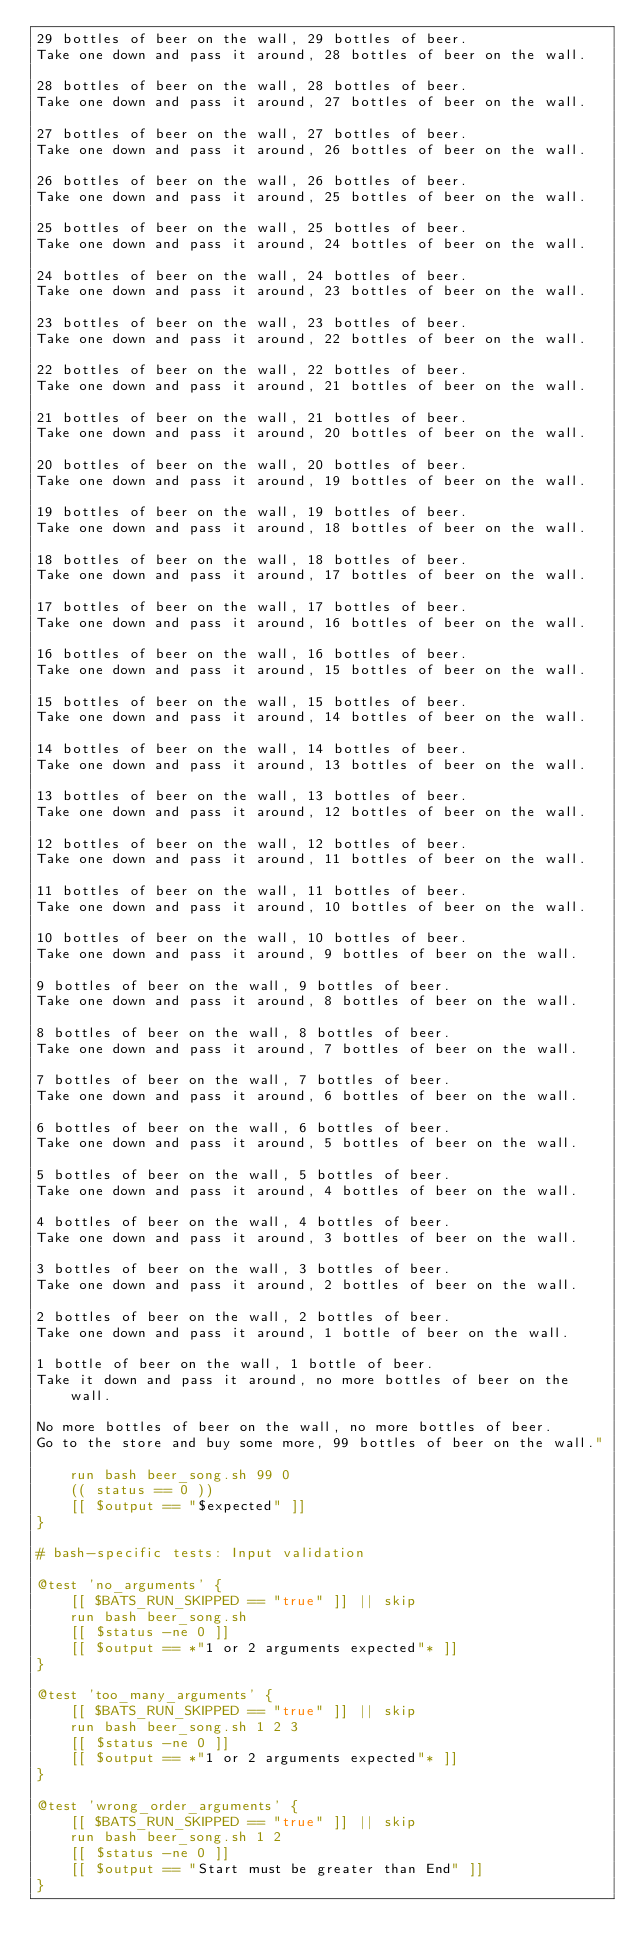Convert code to text. <code><loc_0><loc_0><loc_500><loc_500><_Bash_>29 bottles of beer on the wall, 29 bottles of beer.
Take one down and pass it around, 28 bottles of beer on the wall.

28 bottles of beer on the wall, 28 bottles of beer.
Take one down and pass it around, 27 bottles of beer on the wall.

27 bottles of beer on the wall, 27 bottles of beer.
Take one down and pass it around, 26 bottles of beer on the wall.

26 bottles of beer on the wall, 26 bottles of beer.
Take one down and pass it around, 25 bottles of beer on the wall.

25 bottles of beer on the wall, 25 bottles of beer.
Take one down and pass it around, 24 bottles of beer on the wall.

24 bottles of beer on the wall, 24 bottles of beer.
Take one down and pass it around, 23 bottles of beer on the wall.

23 bottles of beer on the wall, 23 bottles of beer.
Take one down and pass it around, 22 bottles of beer on the wall.

22 bottles of beer on the wall, 22 bottles of beer.
Take one down and pass it around, 21 bottles of beer on the wall.

21 bottles of beer on the wall, 21 bottles of beer.
Take one down and pass it around, 20 bottles of beer on the wall.

20 bottles of beer on the wall, 20 bottles of beer.
Take one down and pass it around, 19 bottles of beer on the wall.

19 bottles of beer on the wall, 19 bottles of beer.
Take one down and pass it around, 18 bottles of beer on the wall.

18 bottles of beer on the wall, 18 bottles of beer.
Take one down and pass it around, 17 bottles of beer on the wall.

17 bottles of beer on the wall, 17 bottles of beer.
Take one down and pass it around, 16 bottles of beer on the wall.

16 bottles of beer on the wall, 16 bottles of beer.
Take one down and pass it around, 15 bottles of beer on the wall.

15 bottles of beer on the wall, 15 bottles of beer.
Take one down and pass it around, 14 bottles of beer on the wall.

14 bottles of beer on the wall, 14 bottles of beer.
Take one down and pass it around, 13 bottles of beer on the wall.

13 bottles of beer on the wall, 13 bottles of beer.
Take one down and pass it around, 12 bottles of beer on the wall.

12 bottles of beer on the wall, 12 bottles of beer.
Take one down and pass it around, 11 bottles of beer on the wall.

11 bottles of beer on the wall, 11 bottles of beer.
Take one down and pass it around, 10 bottles of beer on the wall.

10 bottles of beer on the wall, 10 bottles of beer.
Take one down and pass it around, 9 bottles of beer on the wall.

9 bottles of beer on the wall, 9 bottles of beer.
Take one down and pass it around, 8 bottles of beer on the wall.

8 bottles of beer on the wall, 8 bottles of beer.
Take one down and pass it around, 7 bottles of beer on the wall.

7 bottles of beer on the wall, 7 bottles of beer.
Take one down and pass it around, 6 bottles of beer on the wall.

6 bottles of beer on the wall, 6 bottles of beer.
Take one down and pass it around, 5 bottles of beer on the wall.

5 bottles of beer on the wall, 5 bottles of beer.
Take one down and pass it around, 4 bottles of beer on the wall.

4 bottles of beer on the wall, 4 bottles of beer.
Take one down and pass it around, 3 bottles of beer on the wall.

3 bottles of beer on the wall, 3 bottles of beer.
Take one down and pass it around, 2 bottles of beer on the wall.

2 bottles of beer on the wall, 2 bottles of beer.
Take one down and pass it around, 1 bottle of beer on the wall.

1 bottle of beer on the wall, 1 bottle of beer.
Take it down and pass it around, no more bottles of beer on the wall.

No more bottles of beer on the wall, no more bottles of beer.
Go to the store and buy some more, 99 bottles of beer on the wall."

    run bash beer_song.sh 99 0
    (( status == 0 ))
    [[ $output == "$expected" ]]
}

# bash-specific tests: Input validation

@test 'no_arguments' {
    [[ $BATS_RUN_SKIPPED == "true" ]] || skip
    run bash beer_song.sh
    [[ $status -ne 0 ]]
    [[ $output == *"1 or 2 arguments expected"* ]]
}

@test 'too_many_arguments' {
    [[ $BATS_RUN_SKIPPED == "true" ]] || skip
    run bash beer_song.sh 1 2 3
    [[ $status -ne 0 ]]
    [[ $output == *"1 or 2 arguments expected"* ]]
}

@test 'wrong_order_arguments' {
    [[ $BATS_RUN_SKIPPED == "true" ]] || skip
    run bash beer_song.sh 1 2
    [[ $status -ne 0 ]]
    [[ $output == "Start must be greater than End" ]]
}
</code> 